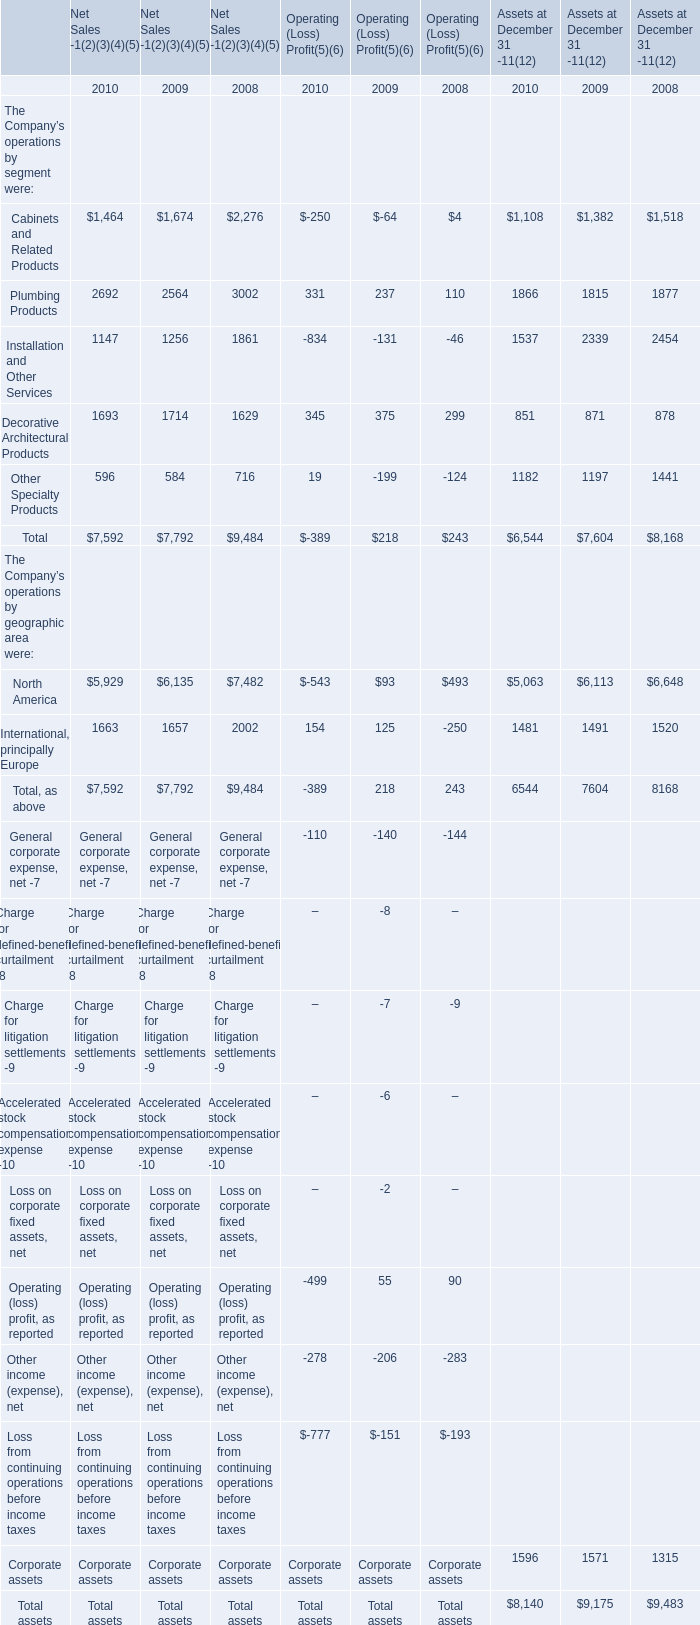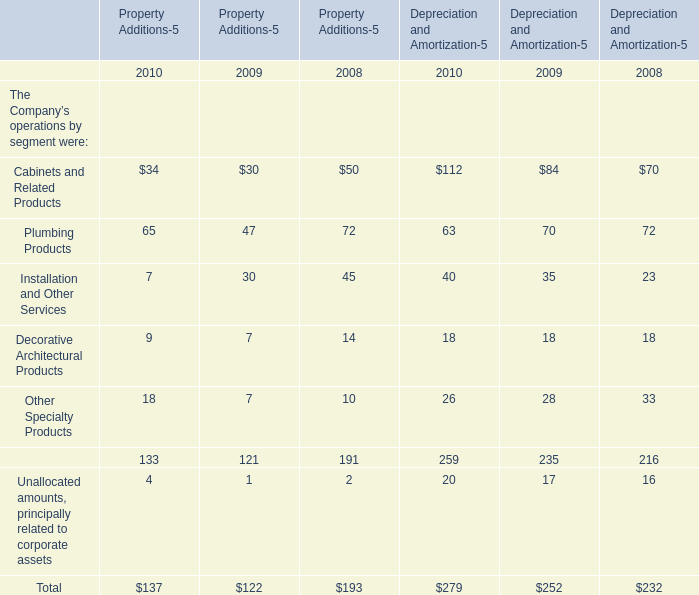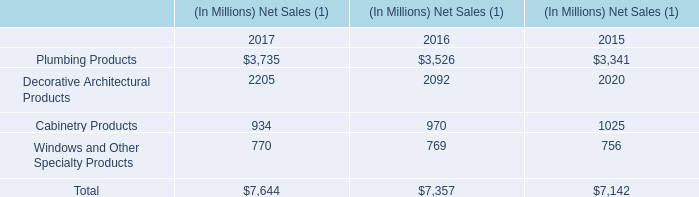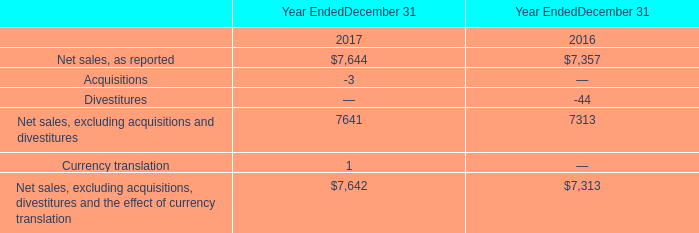What do all Operating (Loss) Profit(5)(6) sum up, excluding those negative ones in 2009 for The Company’s operations by segment were ? 
Computations: ((((-64 + 237) - 131) + 375) - 199)
Answer: 218.0. 